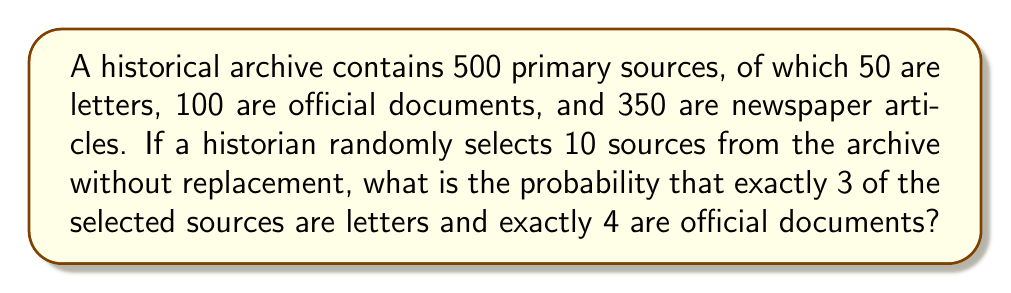Help me with this question. Let's approach this step-by-step using the hypergeometric distribution:

1) We need to select 3 letters, 4 official documents, and 3 newspaper articles (to make up the total of 10 selections).

2) The probability of this specific combination is:

   $$P = \frac{\binom{50}{3} \cdot \binom{100}{4} \cdot \binom{350}{3}}{\binom{500}{10}}$$

3) Let's calculate each part:

   a) $\binom{50}{3}$ (ways to choose 3 letters from 50):
      $$\binom{50}{3} = \frac{50!}{3!(50-3)!} = 19,600$$

   b) $\binom{100}{4}$ (ways to choose 4 official documents from 100):
      $$\binom{100}{4} = \frac{100!}{4!(100-4)!} = 3,921,225$$

   c) $\binom{350}{3}$ (ways to choose 3 newspaper articles from 350):
      $$\binom{350}{3} = \frac{350!}{3!(350-3)!} = 7,140,000$$

   d) $\binom{500}{10}$ (total ways to choose 10 items from 500):
      $$\binom{500}{10} = \frac{500!}{10!(500-10)!} = 2.45 \times 10^{23}$$

4) Now, we can substitute these values into our probability formula:

   $$P = \frac{19,600 \cdot 3,921,225 \cdot 7,140,000}{2.45 \times 10^{23}}$$

5) Calculating this gives us:

   $$P \approx 0.00222$$

Therefore, the probability is approximately 0.00222 or about 0.222%.
Answer: 0.00222 